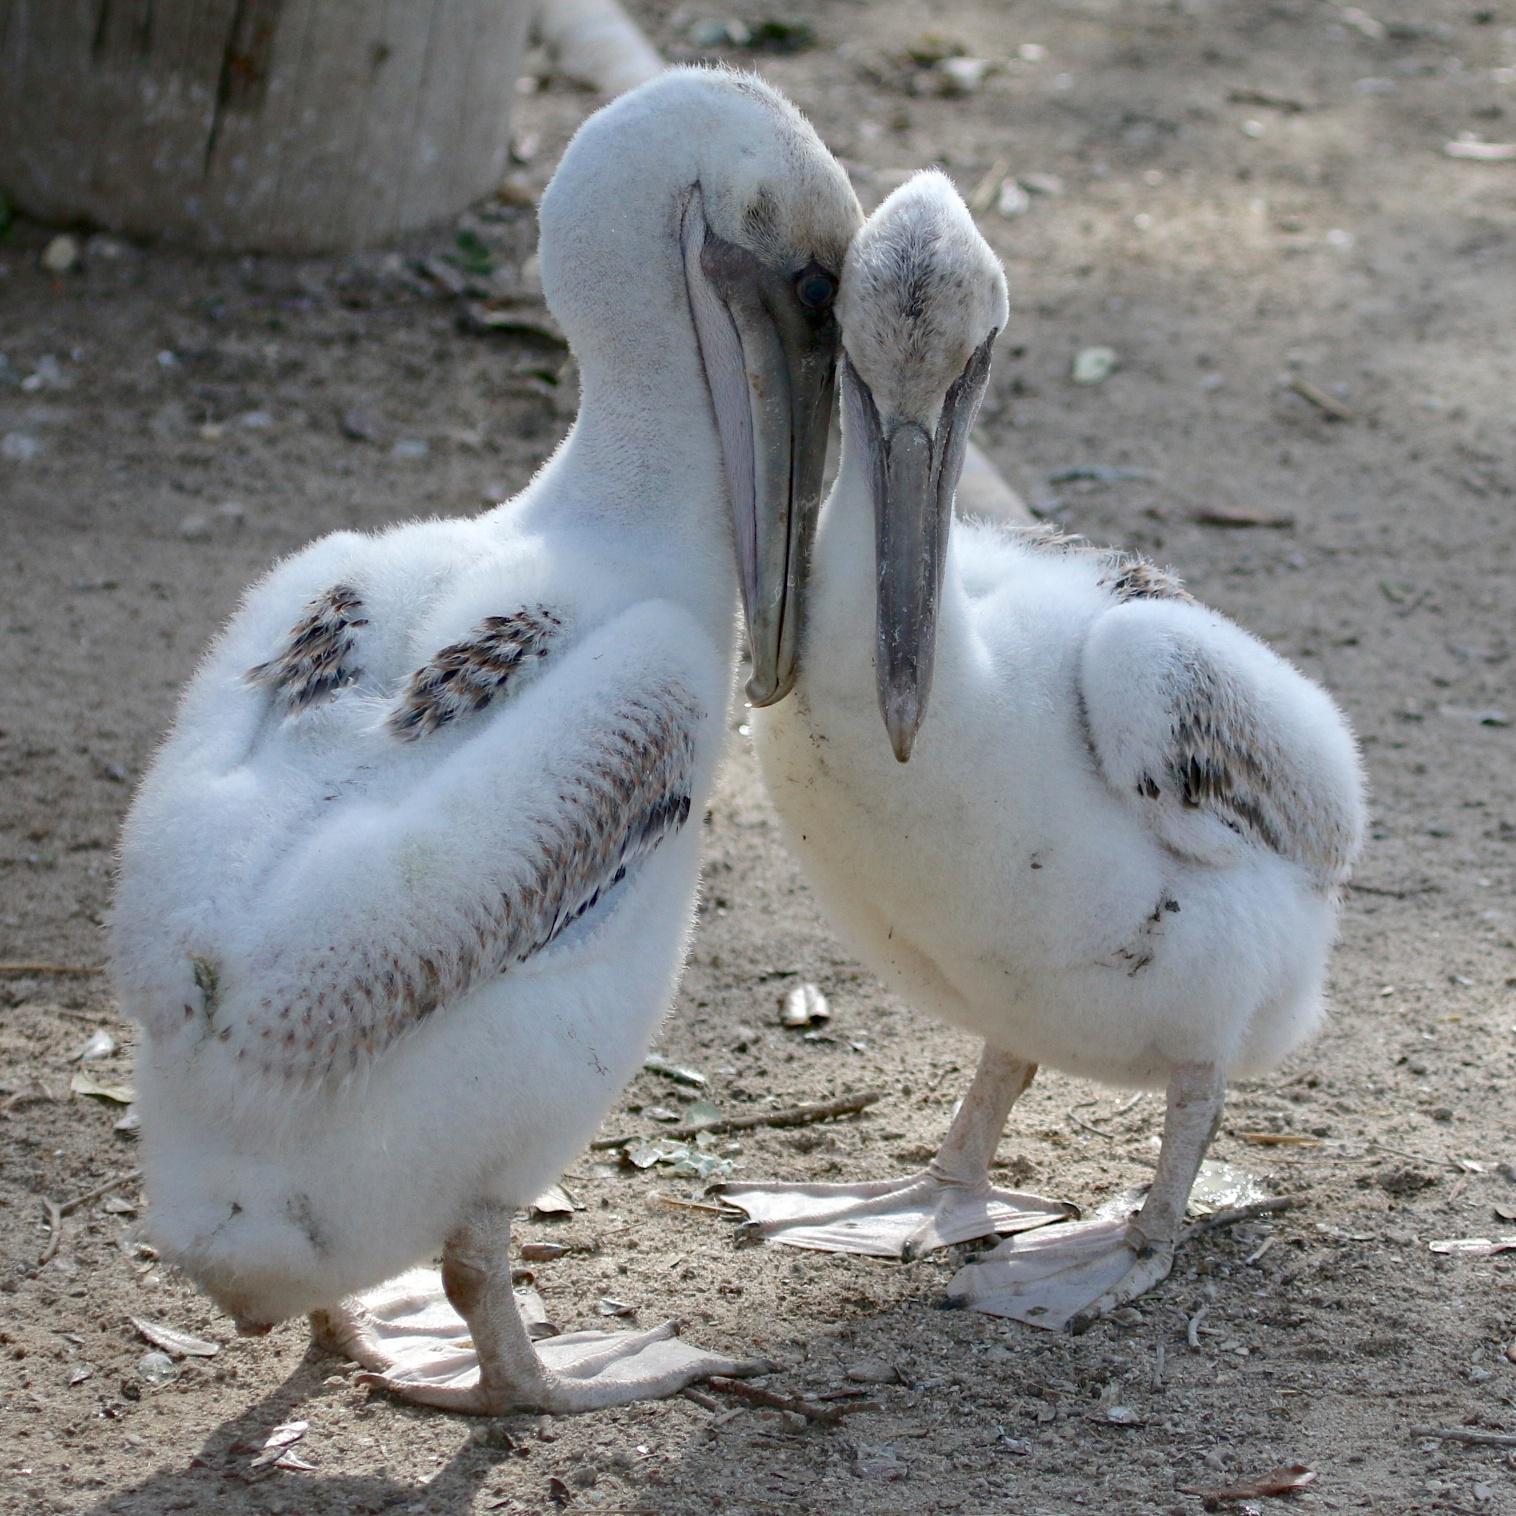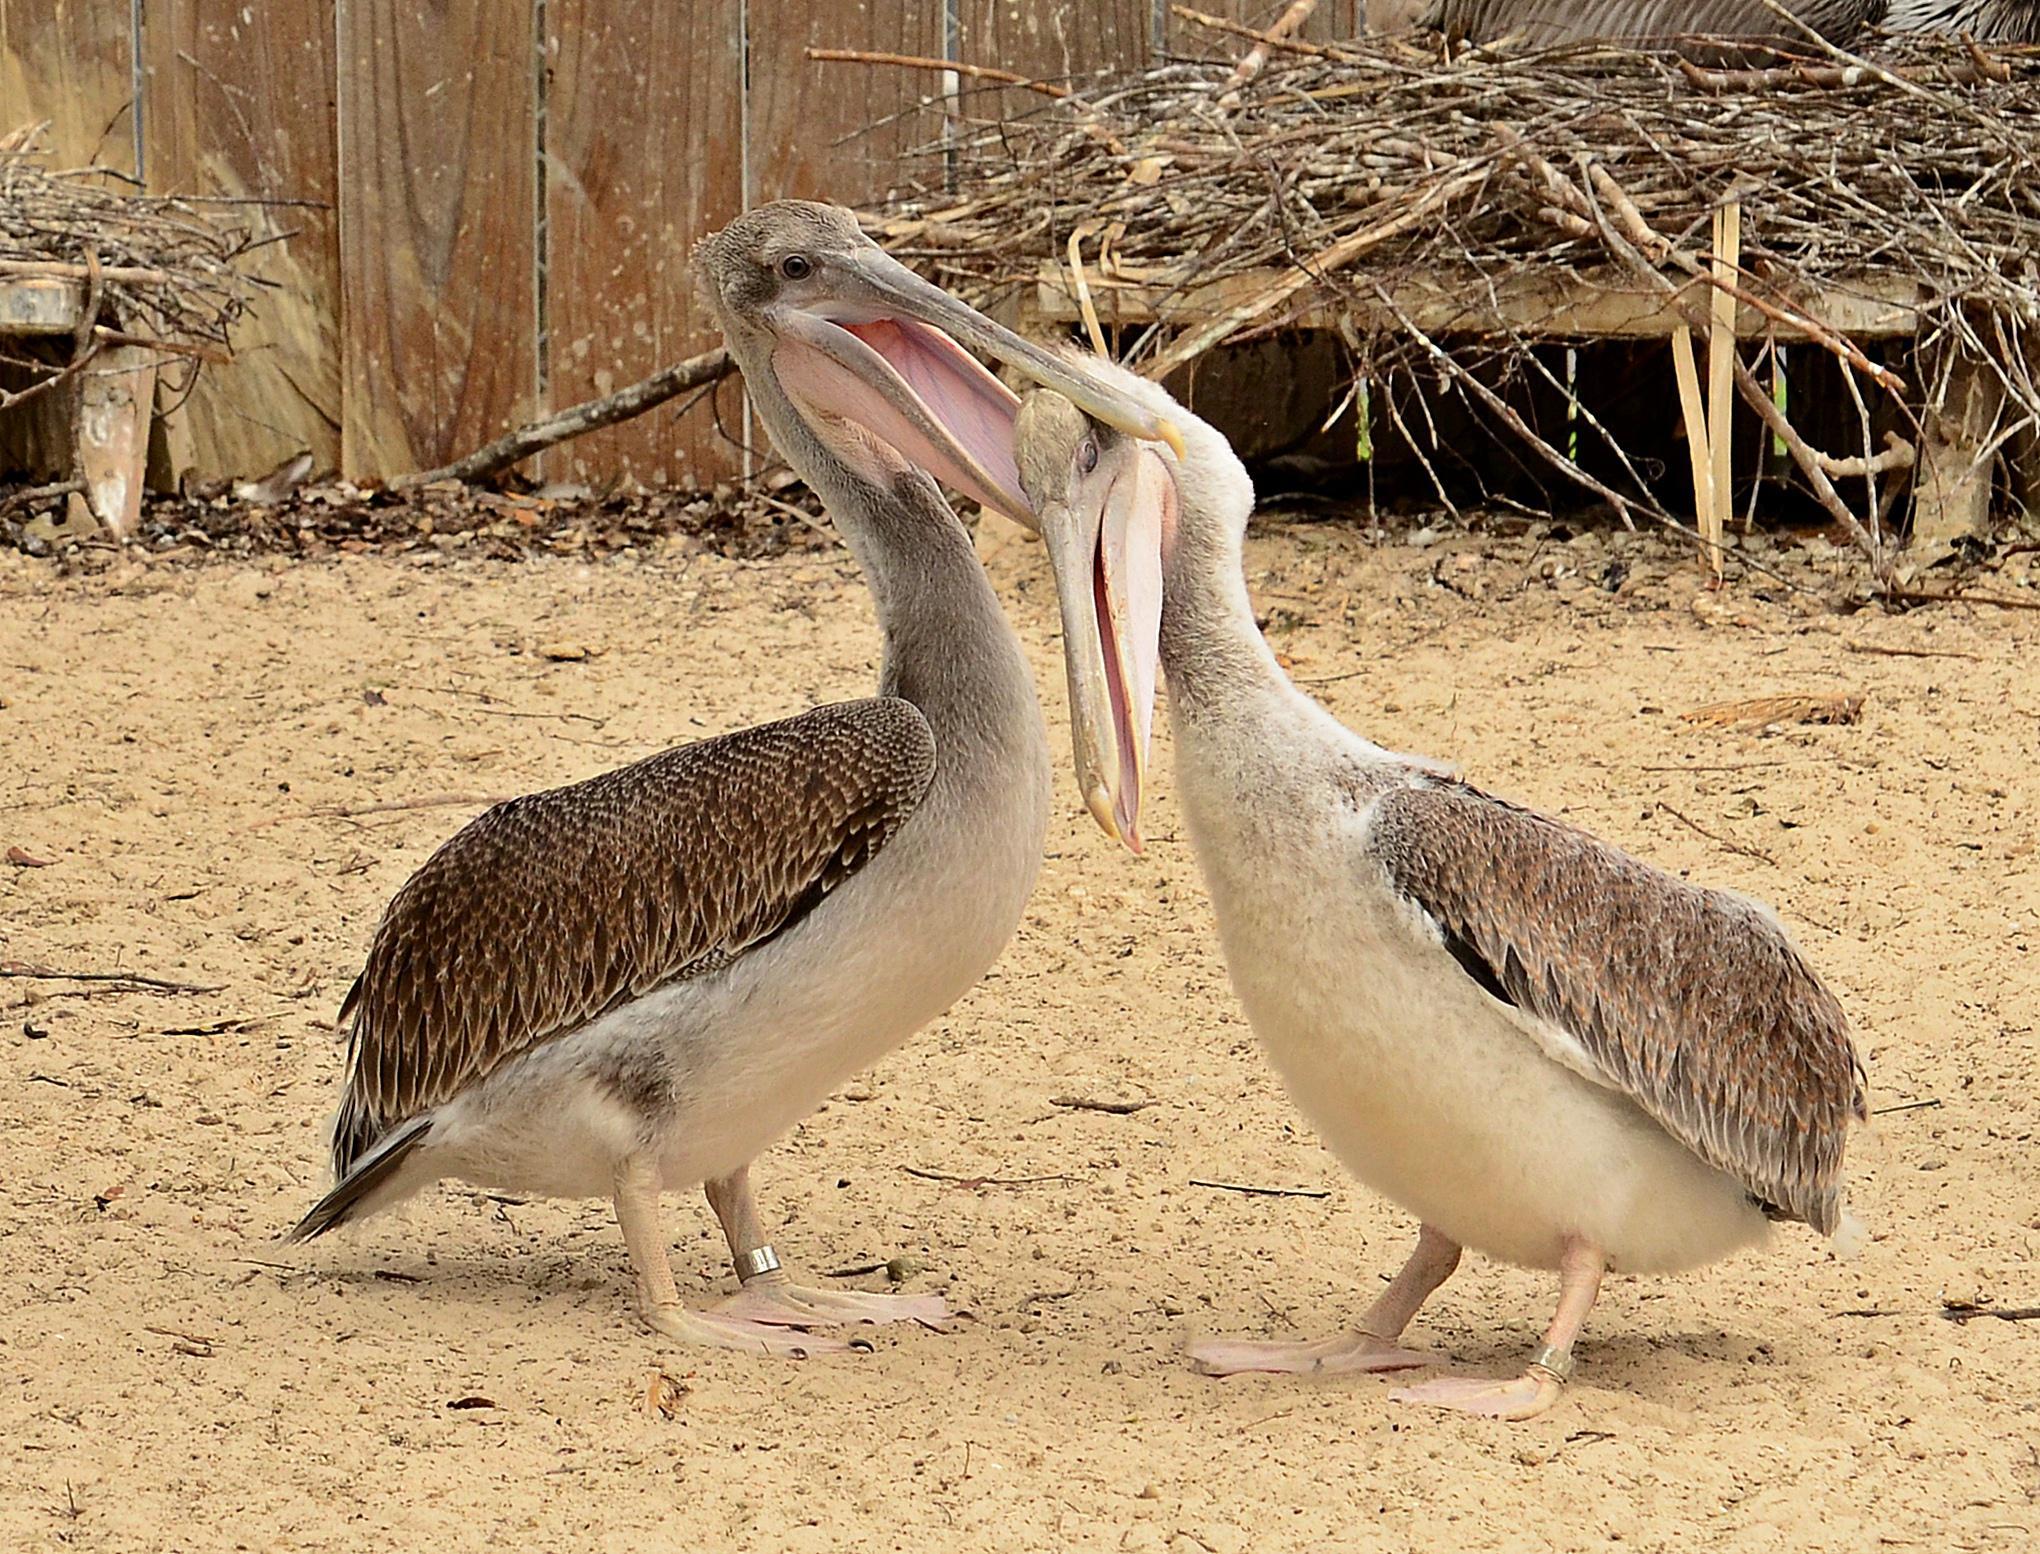The first image is the image on the left, the second image is the image on the right. For the images displayed, is the sentence "There are exactly four birds." factually correct? Answer yes or no. Yes. The first image is the image on the left, the second image is the image on the right. For the images shown, is this caption "Each image shows exactly two pelicans posed close together." true? Answer yes or no. Yes. 